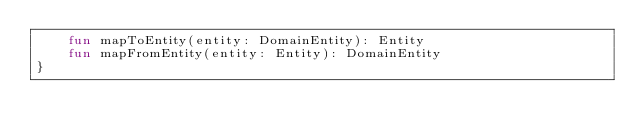<code> <loc_0><loc_0><loc_500><loc_500><_Kotlin_>    fun mapToEntity(entity: DomainEntity): Entity
    fun mapFromEntity(entity: Entity): DomainEntity
}</code> 